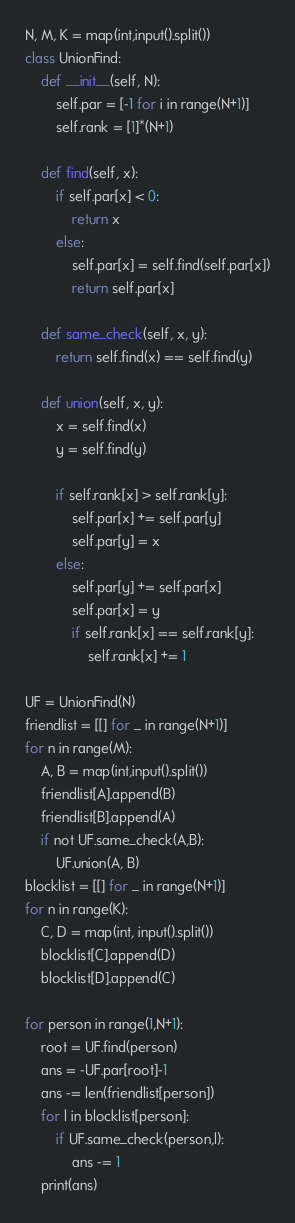<code> <loc_0><loc_0><loc_500><loc_500><_Python_>N, M, K = map(int,input().split())
class UnionFind:
    def __init__(self, N):
        self.par = [-1 for i in range(N+1)]
        self.rank = [1]*(N+1)
    
    def find(self, x):
        if self.par[x] < 0:
            return x
        else:
            self.par[x] = self.find(self.par[x])
            return self.par[x]
        
    def same_check(self, x, y):
        return self.find(x) == self.find(y)
    
    def union(self, x, y):
        x = self.find(x)
        y = self.find(y)
        
        if self.rank[x] > self.rank[y]:
            self.par[x] += self.par[y]
            self.par[y] = x
        else:
            self.par[y] += self.par[x]
            self.par[x] = y
            if self.rank[x] == self.rank[y]:
                self.rank[x] += 1

UF = UnionFind(N)
friendlist = [[] for _ in range(N+1)]
for n in range(M):
    A, B = map(int,input().split())
    friendlist[A].append(B)
    friendlist[B].append(A)
    if not UF.same_check(A,B):
        UF.union(A, B)
blocklist = [[] for _ in range(N+1)]
for n in range(K):
    C, D = map(int, input().split())
    blocklist[C].append(D)
    blocklist[D].append(C)

for person in range(1,N+1):
    root = UF.find(person)
    ans = -UF.par[root]-1
    ans -= len(friendlist[person])
    for l in blocklist[person]:
        if UF.same_check(person,l):
            ans -= 1
    print(ans)</code> 